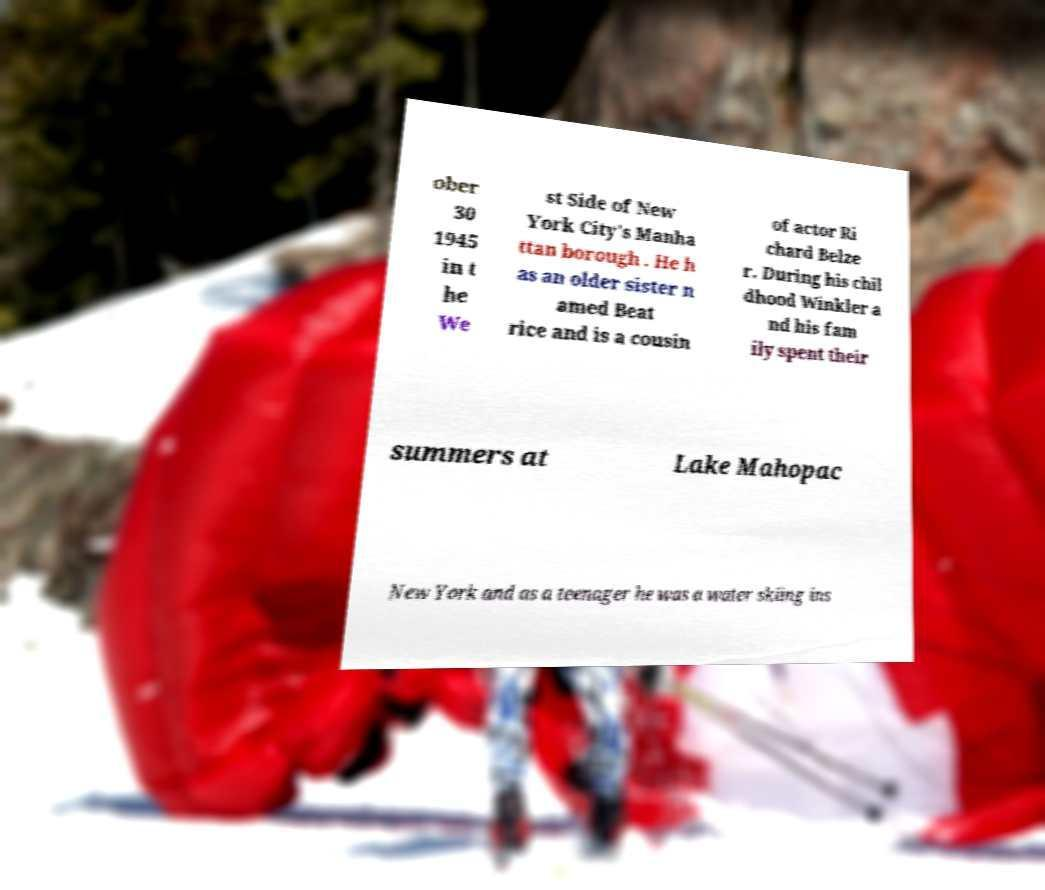Could you extract and type out the text from this image? ober 30 1945 in t he We st Side of New York City's Manha ttan borough . He h as an older sister n amed Beat rice and is a cousin of actor Ri chard Belze r. During his chil dhood Winkler a nd his fam ily spent their summers at Lake Mahopac New York and as a teenager he was a water skiing ins 